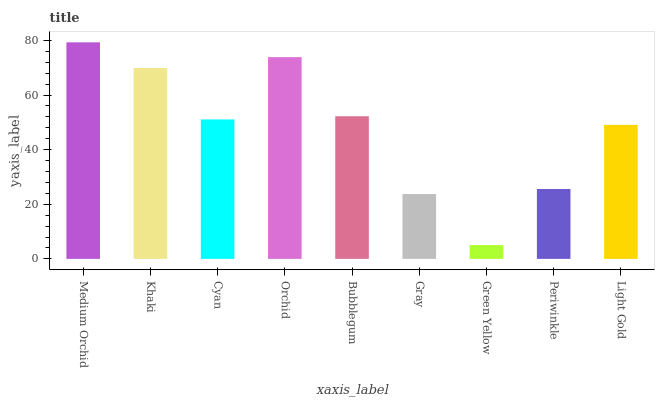Is Green Yellow the minimum?
Answer yes or no. Yes. Is Medium Orchid the maximum?
Answer yes or no. Yes. Is Khaki the minimum?
Answer yes or no. No. Is Khaki the maximum?
Answer yes or no. No. Is Medium Orchid greater than Khaki?
Answer yes or no. Yes. Is Khaki less than Medium Orchid?
Answer yes or no. Yes. Is Khaki greater than Medium Orchid?
Answer yes or no. No. Is Medium Orchid less than Khaki?
Answer yes or no. No. Is Cyan the high median?
Answer yes or no. Yes. Is Cyan the low median?
Answer yes or no. Yes. Is Bubblegum the high median?
Answer yes or no. No. Is Light Gold the low median?
Answer yes or no. No. 